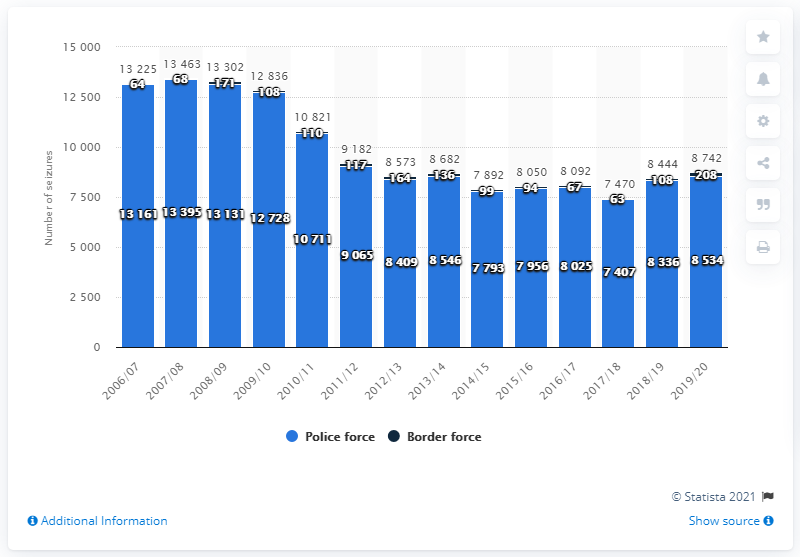Highlight a few significant elements in this photo. In the 2019/2020 financial year, the police and border force seized a total of 8,534 heroin seizures. 